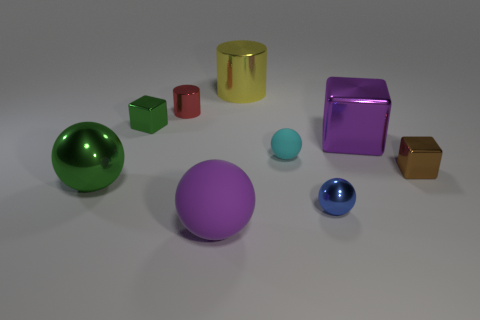Subtract all large purple spheres. How many spheres are left? 3 Subtract 1 balls. How many balls are left? 3 Subtract all red balls. Subtract all red blocks. How many balls are left? 4 Subtract all gray cubes. How many yellow cylinders are left? 1 Subtract all green shiny things. Subtract all large red metallic cubes. How many objects are left? 7 Add 2 small red things. How many small red things are left? 3 Add 4 purple matte balls. How many purple matte balls exist? 5 Add 1 large matte cylinders. How many objects exist? 10 Subtract all cyan spheres. How many spheres are left? 3 Subtract 0 gray cylinders. How many objects are left? 9 